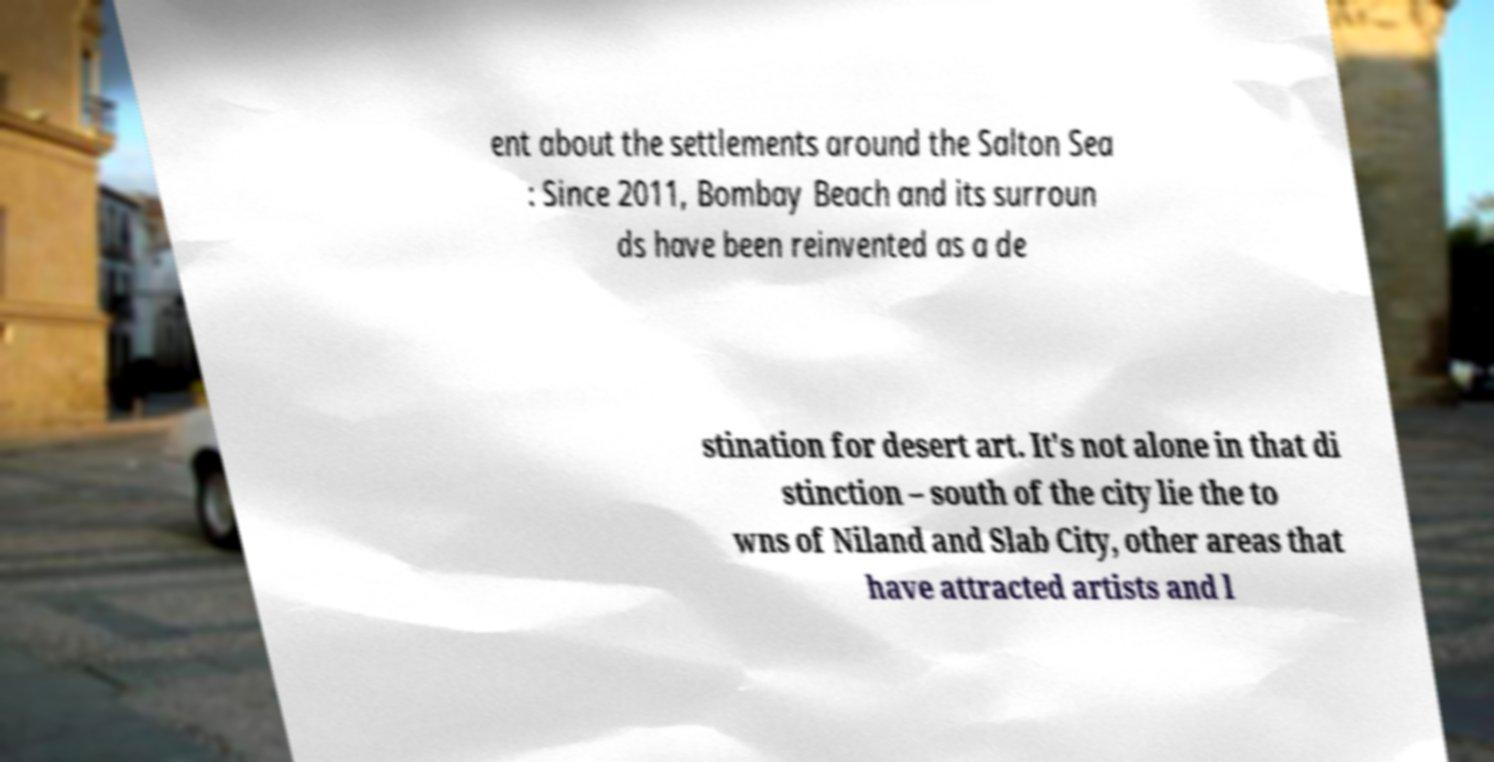Can you accurately transcribe the text from the provided image for me? ent about the settlements around the Salton Sea : Since 2011, Bombay Beach and its surroun ds have been reinvented as a de stination for desert art. It's not alone in that di stinction – south of the city lie the to wns of Niland and Slab City, other areas that have attracted artists and l 